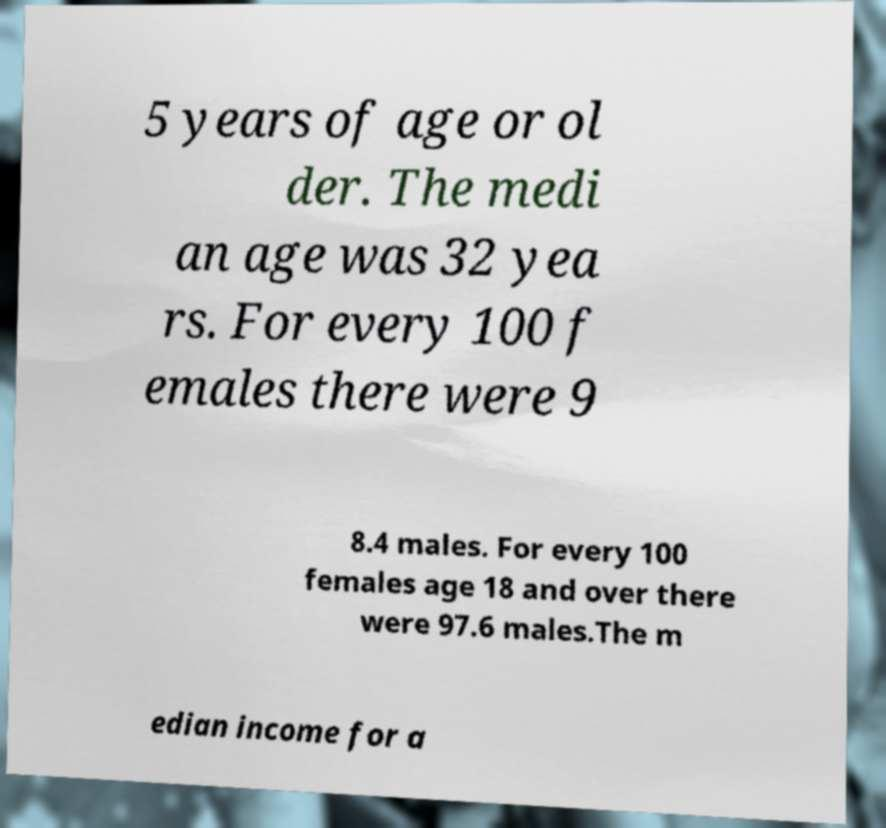What messages or text are displayed in this image? I need them in a readable, typed format. 5 years of age or ol der. The medi an age was 32 yea rs. For every 100 f emales there were 9 8.4 males. For every 100 females age 18 and over there were 97.6 males.The m edian income for a 